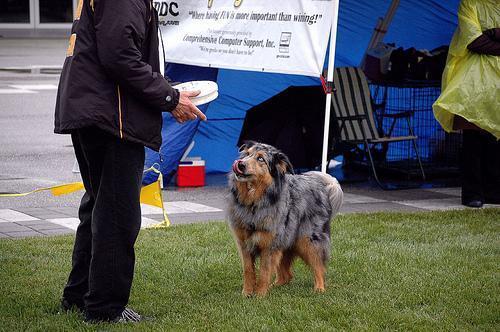How many dogs are in the photo?
Give a very brief answer. 1. 